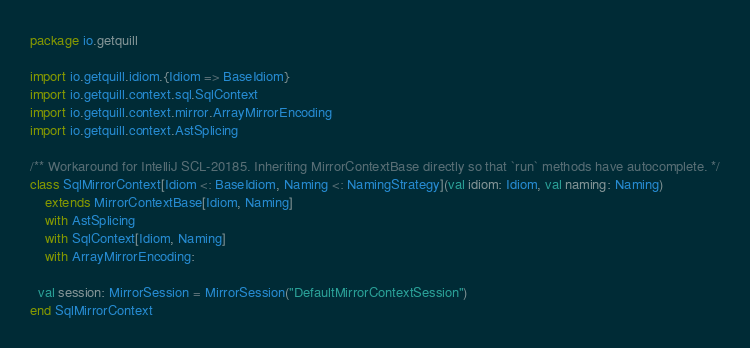Convert code to text. <code><loc_0><loc_0><loc_500><loc_500><_Scala_>package io.getquill

import io.getquill.idiom.{Idiom => BaseIdiom}
import io.getquill.context.sql.SqlContext
import io.getquill.context.mirror.ArrayMirrorEncoding
import io.getquill.context.AstSplicing

/** Workaround for IntelliJ SCL-20185. Inheriting MirrorContextBase directly so that `run` methods have autocomplete. */
class SqlMirrorContext[Idiom <: BaseIdiom, Naming <: NamingStrategy](val idiom: Idiom, val naming: Naming)
    extends MirrorContextBase[Idiom, Naming]
    with AstSplicing
    with SqlContext[Idiom, Naming]
    with ArrayMirrorEncoding:

  val session: MirrorSession = MirrorSession("DefaultMirrorContextSession")
end SqlMirrorContext
</code> 